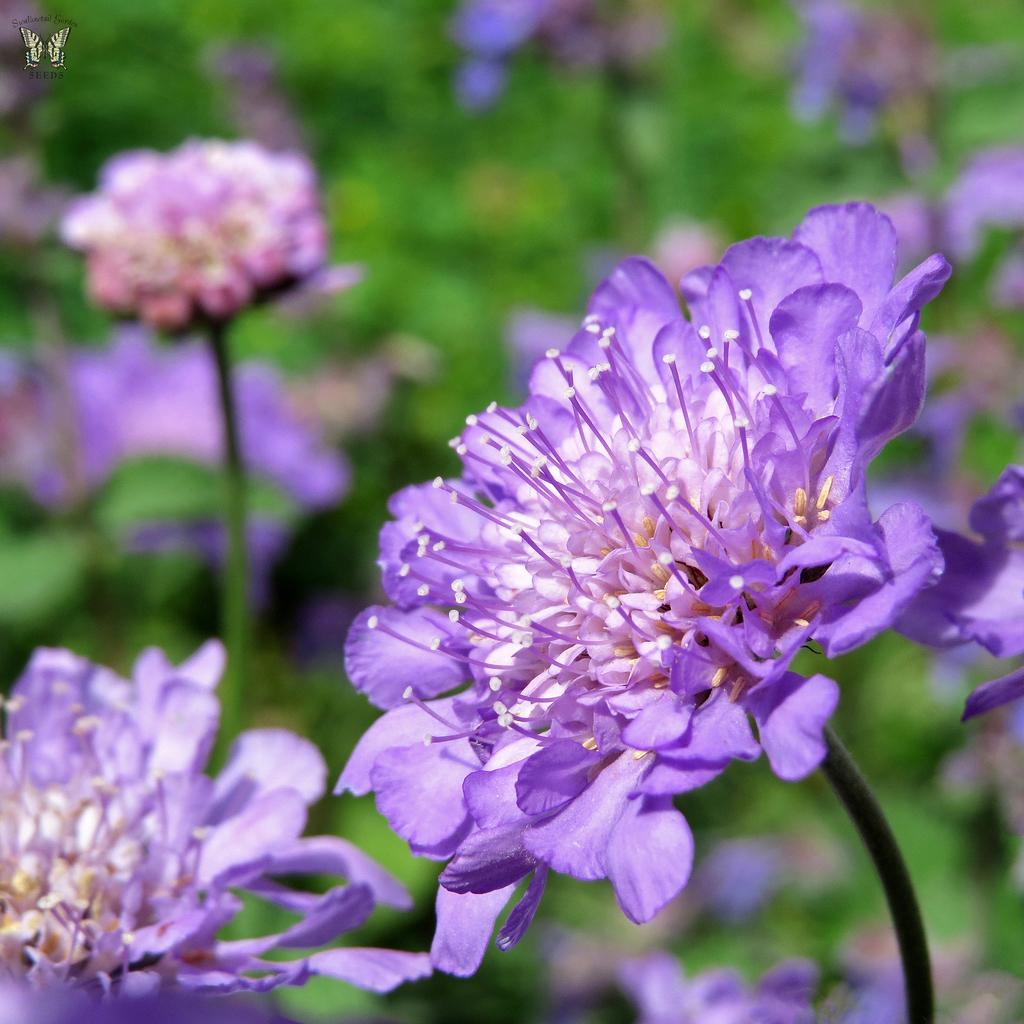What type of flowers can be seen in the image? There are purple color flowers in the image. Where are the flowers located? The flowers are on a plant. What is present in the top left corner of the image? There is a butterfly logo in the top left corner of the image. Can you see any fangs on the flowers in the image? No, there are no fangs present on the flowers in the image. How many cards are visible in the image? There are no cards visible in the image; it features flowers on a plant and a butterfly logo. 